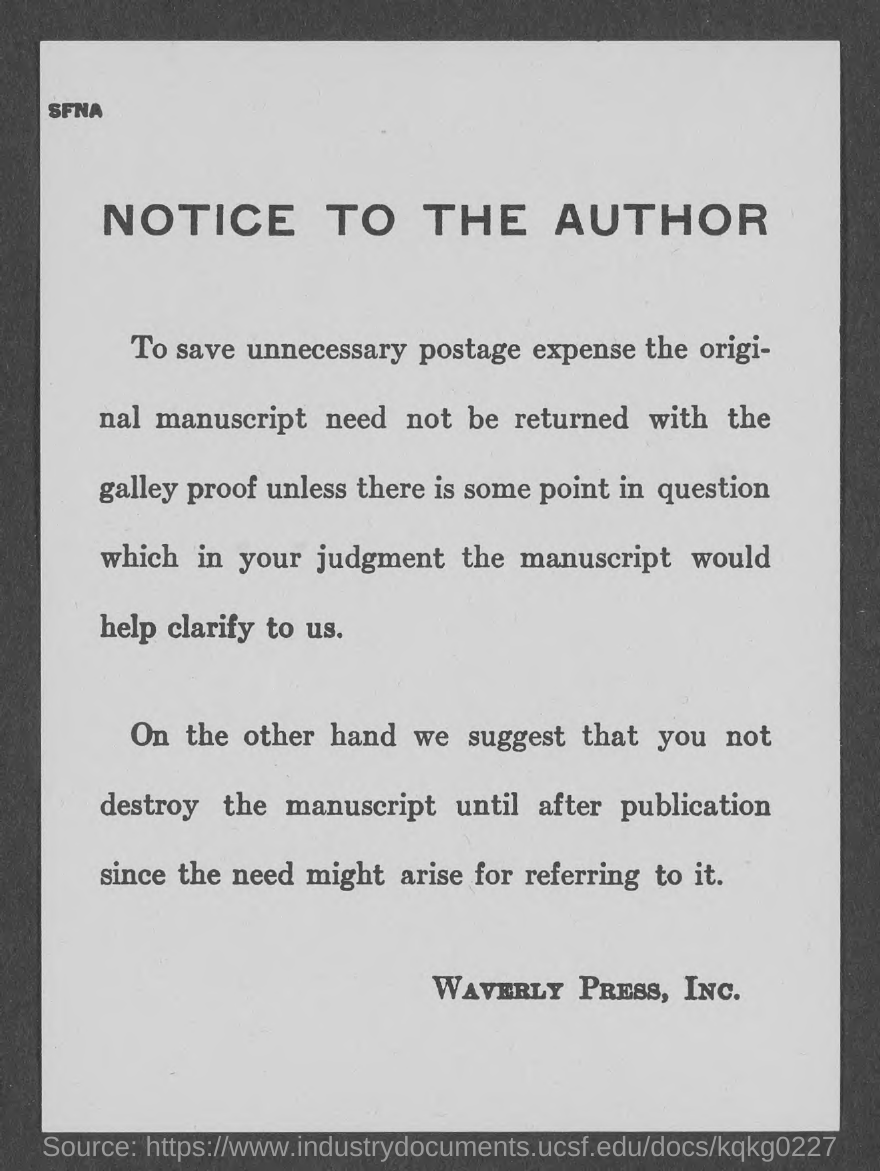Highlight a few significant elements in this photo. The document title is 'Notice to the Author.' The notice has been issued by Waverly Press, Inc... 